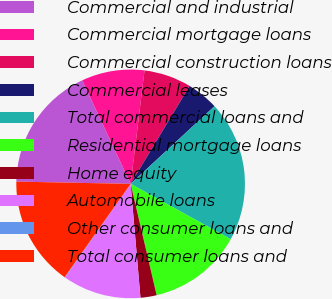Convert chart. <chart><loc_0><loc_0><loc_500><loc_500><pie_chart><fcel>Commercial and industrial<fcel>Commercial mortgage loans<fcel>Commercial construction loans<fcel>Commercial leases<fcel>Total commercial loans and<fcel>Residential mortgage loans<fcel>Home equity<fcel>Automobile loans<fcel>Other consumer loans and<fcel>Total consumer loans and<nl><fcel>17.72%<fcel>8.9%<fcel>6.69%<fcel>4.48%<fcel>19.93%<fcel>13.31%<fcel>2.28%<fcel>11.1%<fcel>0.07%<fcel>15.52%<nl></chart> 